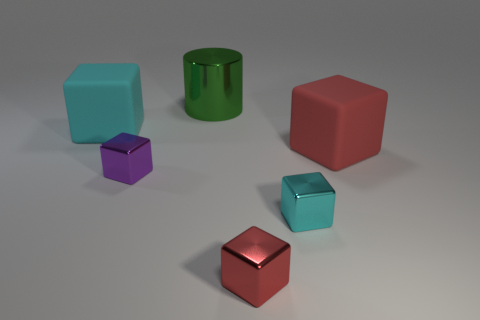Add 2 small red rubber things. How many objects exist? 8 Subtract all big cyan blocks. How many blocks are left? 4 Subtract all cyan blocks. How many blocks are left? 3 Subtract all red balls. How many cyan blocks are left? 2 Subtract all small purple shiny blocks. Subtract all green shiny cylinders. How many objects are left? 4 Add 2 large red rubber cubes. How many large red rubber cubes are left? 3 Add 3 matte objects. How many matte objects exist? 5 Subtract 0 gray blocks. How many objects are left? 6 Subtract all cylinders. How many objects are left? 5 Subtract 2 blocks. How many blocks are left? 3 